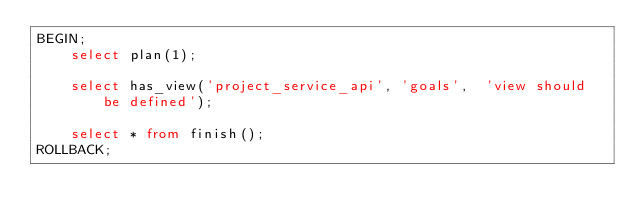<code> <loc_0><loc_0><loc_500><loc_500><_SQL_>BEGIN;
    select plan(1);

    select has_view('project_service_api', 'goals',  'view should be defined');

    select * from finish();
ROLLBACK;
</code> 